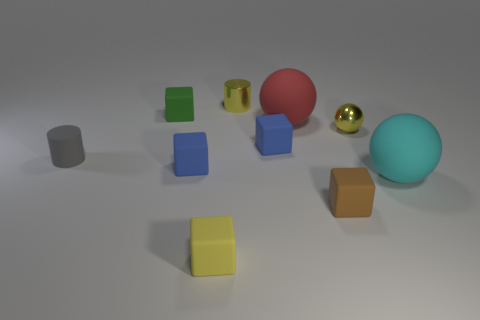Subtract all small yellow cubes. How many cubes are left? 4 Subtract 1 yellow blocks. How many objects are left? 9 Subtract all spheres. How many objects are left? 7 Subtract 1 spheres. How many spheres are left? 2 Subtract all green cubes. Subtract all cyan cylinders. How many cubes are left? 4 Subtract all green cubes. How many cyan spheres are left? 1 Subtract all cyan matte balls. Subtract all large red rubber objects. How many objects are left? 8 Add 9 gray rubber cylinders. How many gray rubber cylinders are left? 10 Add 7 tiny yellow cylinders. How many tiny yellow cylinders exist? 8 Subtract all green cubes. How many cubes are left? 4 